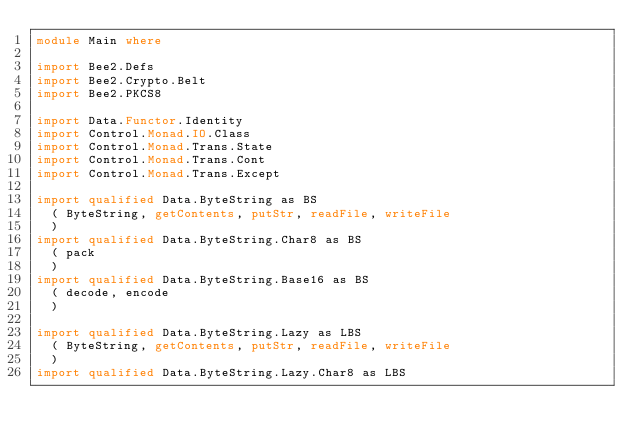<code> <loc_0><loc_0><loc_500><loc_500><_Haskell_>module Main where

import Bee2.Defs
import Bee2.Crypto.Belt
import Bee2.PKCS8

import Data.Functor.Identity
import Control.Monad.IO.Class
import Control.Monad.Trans.State
import Control.Monad.Trans.Cont
import Control.Monad.Trans.Except

import qualified Data.ByteString as BS
  ( ByteString, getContents, putStr, readFile, writeFile
  )
import qualified Data.ByteString.Char8 as BS
  ( pack
  )
import qualified Data.ByteString.Base16 as BS
  ( decode, encode
  )

import qualified Data.ByteString.Lazy as LBS
  ( ByteString, getContents, putStr, readFile, writeFile
  )
import qualified Data.ByteString.Lazy.Char8 as LBS</code> 